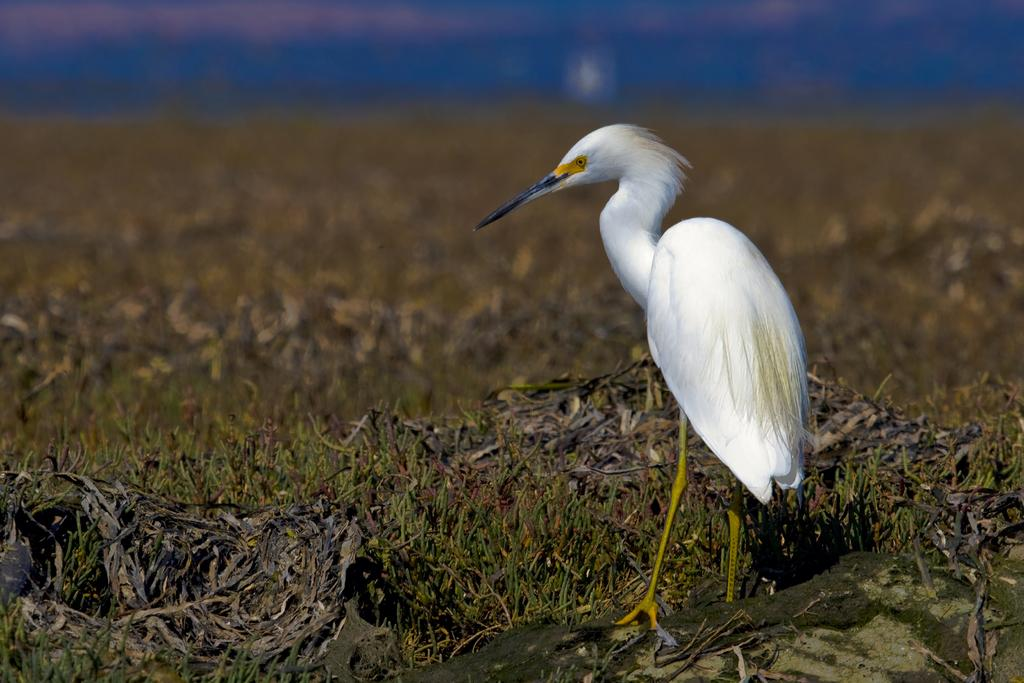What type of bird is in the image? There is a Snowy egret in the image. Where is the Snowy egret located in the image? The Snowy egret is on the right side of the image. What type of terrain is the Snowy egret standing on? The Snowy egret is on grass land. Can you describe the background of the image? The background of the image is blurred. What type of door can be seen in the image? There is no door present in the image; it features a Snowy egret on grass land. 